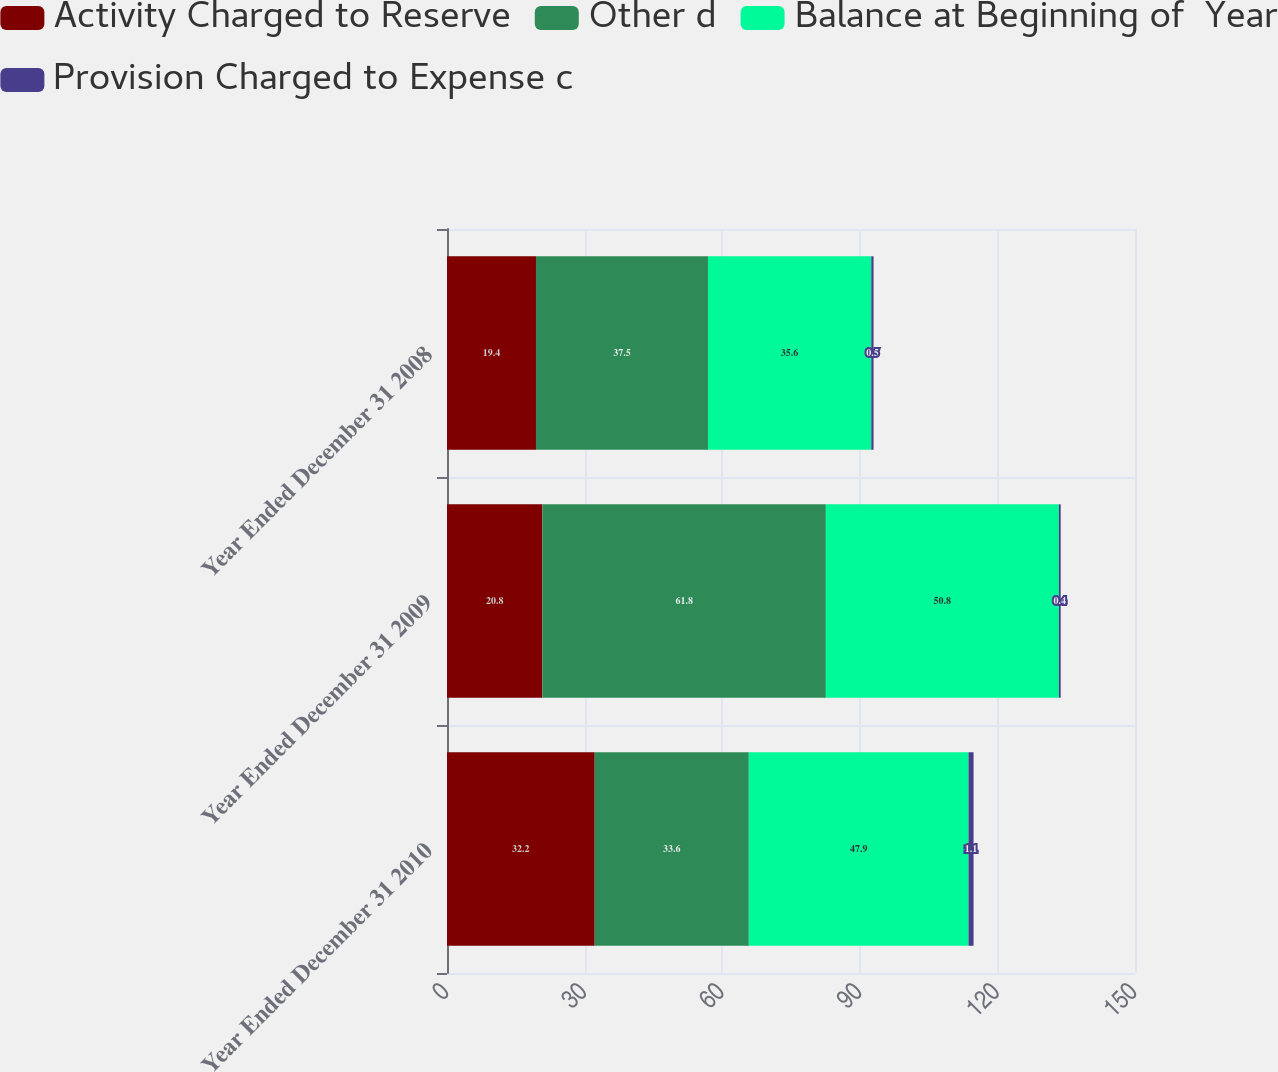Convert chart to OTSL. <chart><loc_0><loc_0><loc_500><loc_500><stacked_bar_chart><ecel><fcel>Year Ended December 31 2010<fcel>Year Ended December 31 2009<fcel>Year Ended December 31 2008<nl><fcel>Activity Charged to Reserve<fcel>32.2<fcel>20.8<fcel>19.4<nl><fcel>Other d<fcel>33.6<fcel>61.8<fcel>37.5<nl><fcel>Balance at Beginning of  Year<fcel>47.9<fcel>50.8<fcel>35.6<nl><fcel>Provision Charged to Expense c<fcel>1.1<fcel>0.4<fcel>0.5<nl></chart> 